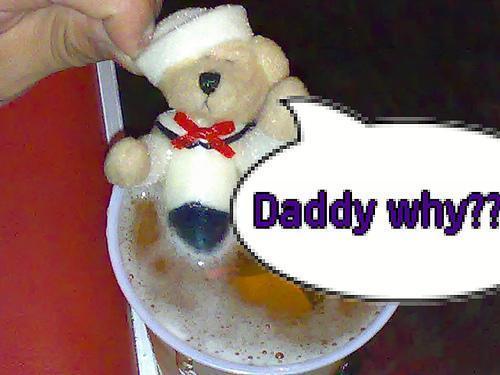How many hands are in this picture?
Give a very brief answer. 1. 